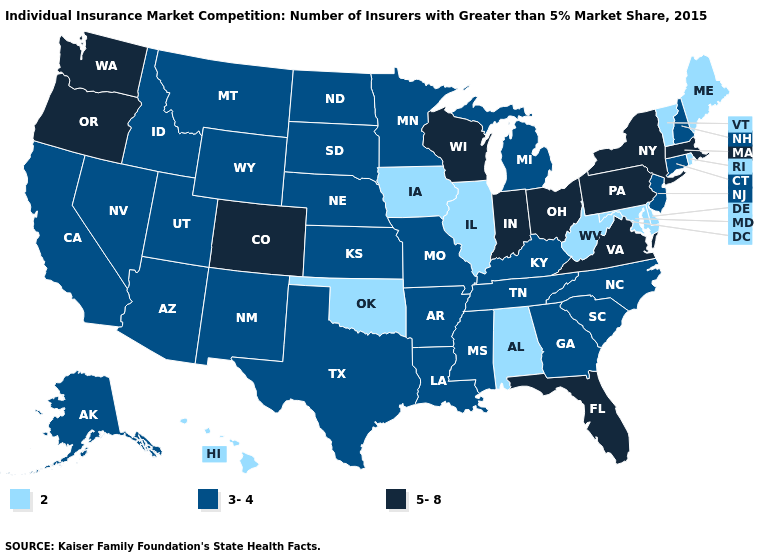Does Hawaii have the lowest value in the West?
Concise answer only. Yes. Does Kentucky have a lower value than Delaware?
Answer briefly. No. What is the lowest value in the Northeast?
Keep it brief. 2. How many symbols are there in the legend?
Write a very short answer. 3. What is the value of Delaware?
Give a very brief answer. 2. Does Missouri have a higher value than Hawaii?
Concise answer only. Yes. Name the states that have a value in the range 5-8?
Write a very short answer. Colorado, Florida, Indiana, Massachusetts, New York, Ohio, Oregon, Pennsylvania, Virginia, Washington, Wisconsin. What is the value of Georgia?
Concise answer only. 3-4. Which states have the lowest value in the MidWest?
Answer briefly. Illinois, Iowa. Which states hav the highest value in the MidWest?
Quick response, please. Indiana, Ohio, Wisconsin. What is the highest value in the South ?
Give a very brief answer. 5-8. What is the lowest value in states that border Montana?
Concise answer only. 3-4. Name the states that have a value in the range 3-4?
Keep it brief. Alaska, Arizona, Arkansas, California, Connecticut, Georgia, Idaho, Kansas, Kentucky, Louisiana, Michigan, Minnesota, Mississippi, Missouri, Montana, Nebraska, Nevada, New Hampshire, New Jersey, New Mexico, North Carolina, North Dakota, South Carolina, South Dakota, Tennessee, Texas, Utah, Wyoming. Does the first symbol in the legend represent the smallest category?
Concise answer only. Yes. What is the value of Georgia?
Write a very short answer. 3-4. 